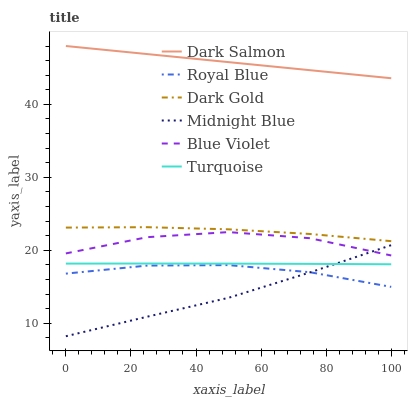Does Midnight Blue have the minimum area under the curve?
Answer yes or no. Yes. Does Dark Salmon have the maximum area under the curve?
Answer yes or no. Yes. Does Dark Gold have the minimum area under the curve?
Answer yes or no. No. Does Dark Gold have the maximum area under the curve?
Answer yes or no. No. Is Dark Salmon the smoothest?
Answer yes or no. Yes. Is Blue Violet the roughest?
Answer yes or no. Yes. Is Midnight Blue the smoothest?
Answer yes or no. No. Is Midnight Blue the roughest?
Answer yes or no. No. Does Dark Gold have the lowest value?
Answer yes or no. No. Does Midnight Blue have the highest value?
Answer yes or no. No. Is Turquoise less than Dark Salmon?
Answer yes or no. Yes. Is Dark Salmon greater than Royal Blue?
Answer yes or no. Yes. Does Turquoise intersect Dark Salmon?
Answer yes or no. No. 